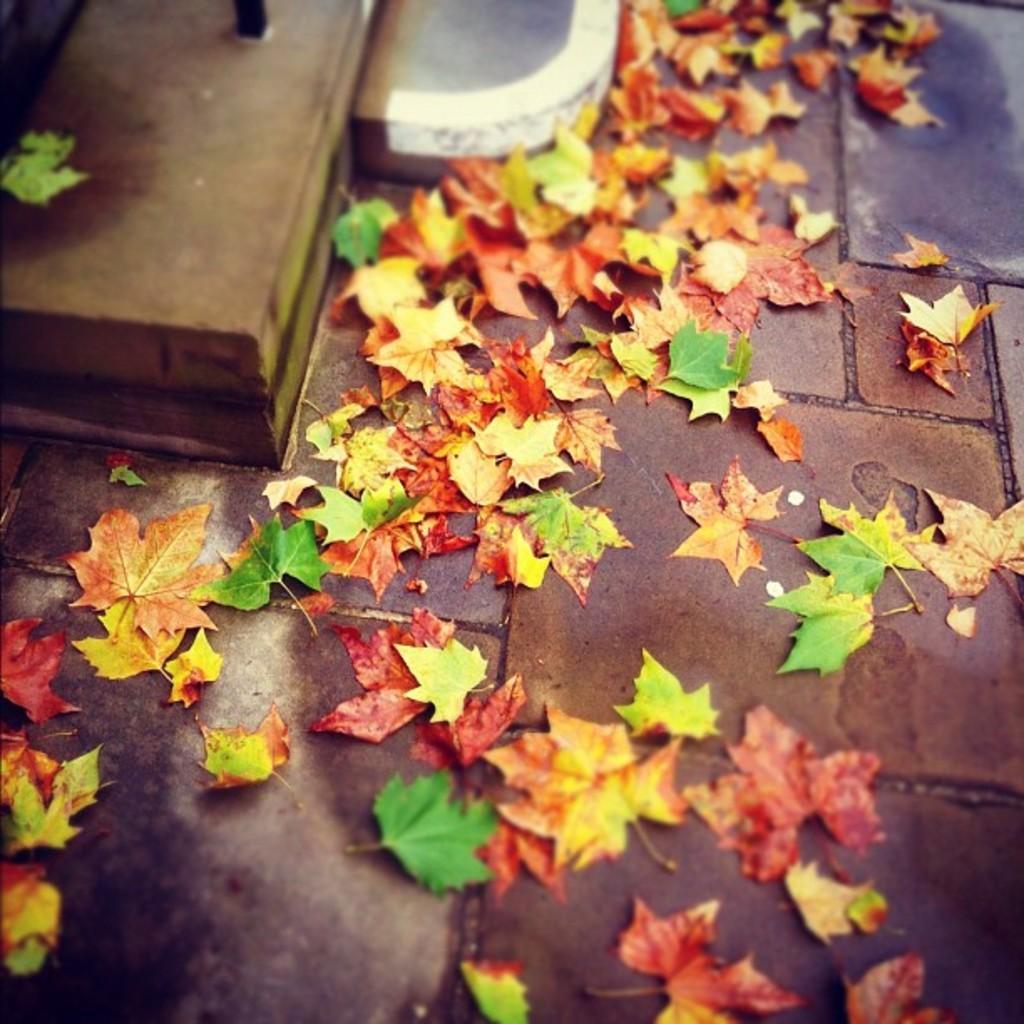Could you give a brief overview of what you see in this image? The picture consists of dry leaves and leaves. At the top it is staircase. At the bottom it is pavement. 